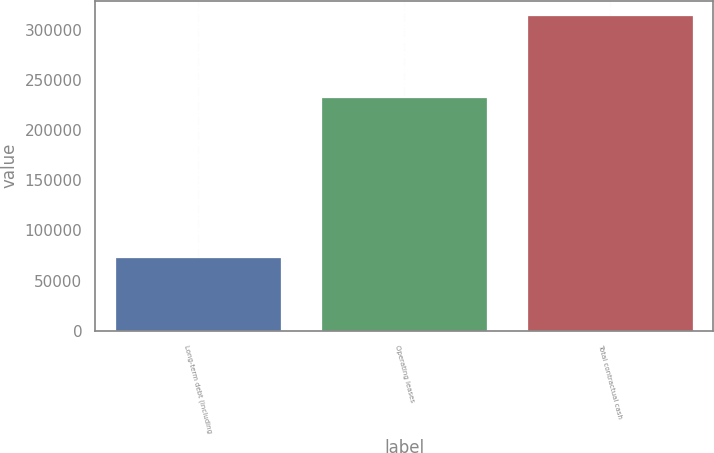Convert chart. <chart><loc_0><loc_0><loc_500><loc_500><bar_chart><fcel>Long-term debt (including<fcel>Operating leases<fcel>Total contractual cash<nl><fcel>72688<fcel>232175<fcel>313222<nl></chart> 